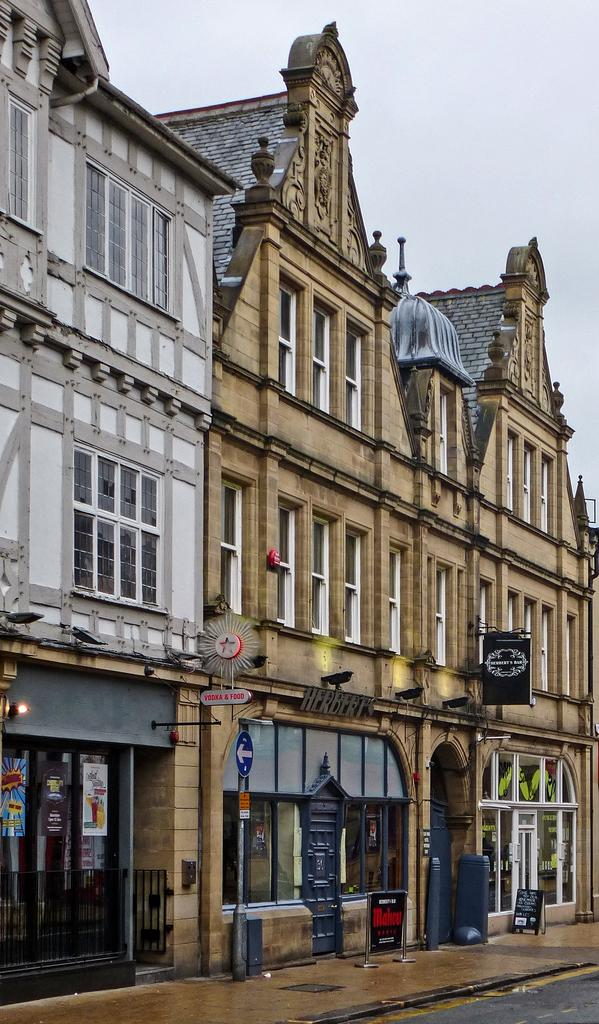What type of structures are present in the image? There are buildings in the image. What additional information can be found in the image? There is a sign board in the image. Are there any other features attached to the buildings? Yes, there are boards attached to the building. What else can be seen on the ground in the image? There are other objects on the ground in the image. What can be seen in the background of the image? The sky is visible in the background of the image. Can you see a van with a net attached to it in the image? No, there is no van or net present in the image. 